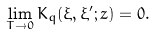Convert formula to latex. <formula><loc_0><loc_0><loc_500><loc_500>\lim _ { T \rightarrow 0 } K _ { q } ( \xi , \xi ^ { \prime } ; z ) = 0 .</formula> 